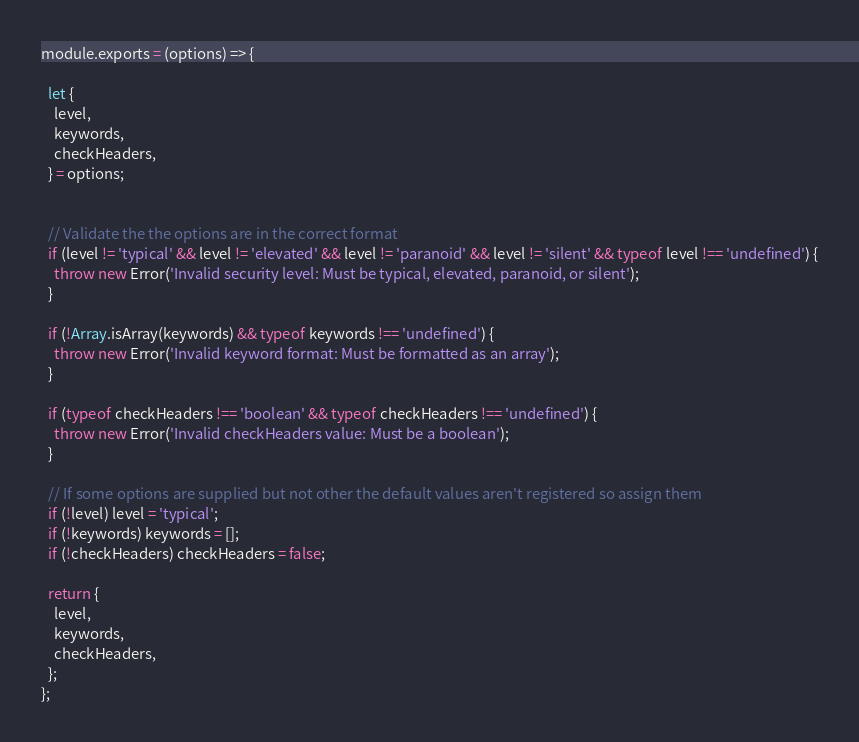<code> <loc_0><loc_0><loc_500><loc_500><_JavaScript_>module.exports = (options) => {

  let {
    level,
    keywords,
    checkHeaders,
  } = options;


  // Validate the the options are in the correct format
  if (level != 'typical' && level != 'elevated' && level != 'paranoid' && level != 'silent' && typeof level !== 'undefined') {
    throw new Error('Invalid security level: Must be typical, elevated, paranoid, or silent');
  }

  if (!Array.isArray(keywords) && typeof keywords !== 'undefined') {
    throw new Error('Invalid keyword format: Must be formatted as an array');
  }

  if (typeof checkHeaders !== 'boolean' && typeof checkHeaders !== 'undefined') {
    throw new Error('Invalid checkHeaders value: Must be a boolean');
  }

  // If some options are supplied but not other the default values aren't registered so assign them
  if (!level) level = 'typical';
  if (!keywords) keywords = [];
  if (!checkHeaders) checkHeaders = false;

  return {
    level,
    keywords,
    checkHeaders,
  };
};</code> 